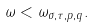Convert formula to latex. <formula><loc_0><loc_0><loc_500><loc_500>\omega < \omega _ { \sigma , \tau , p , q } .</formula> 